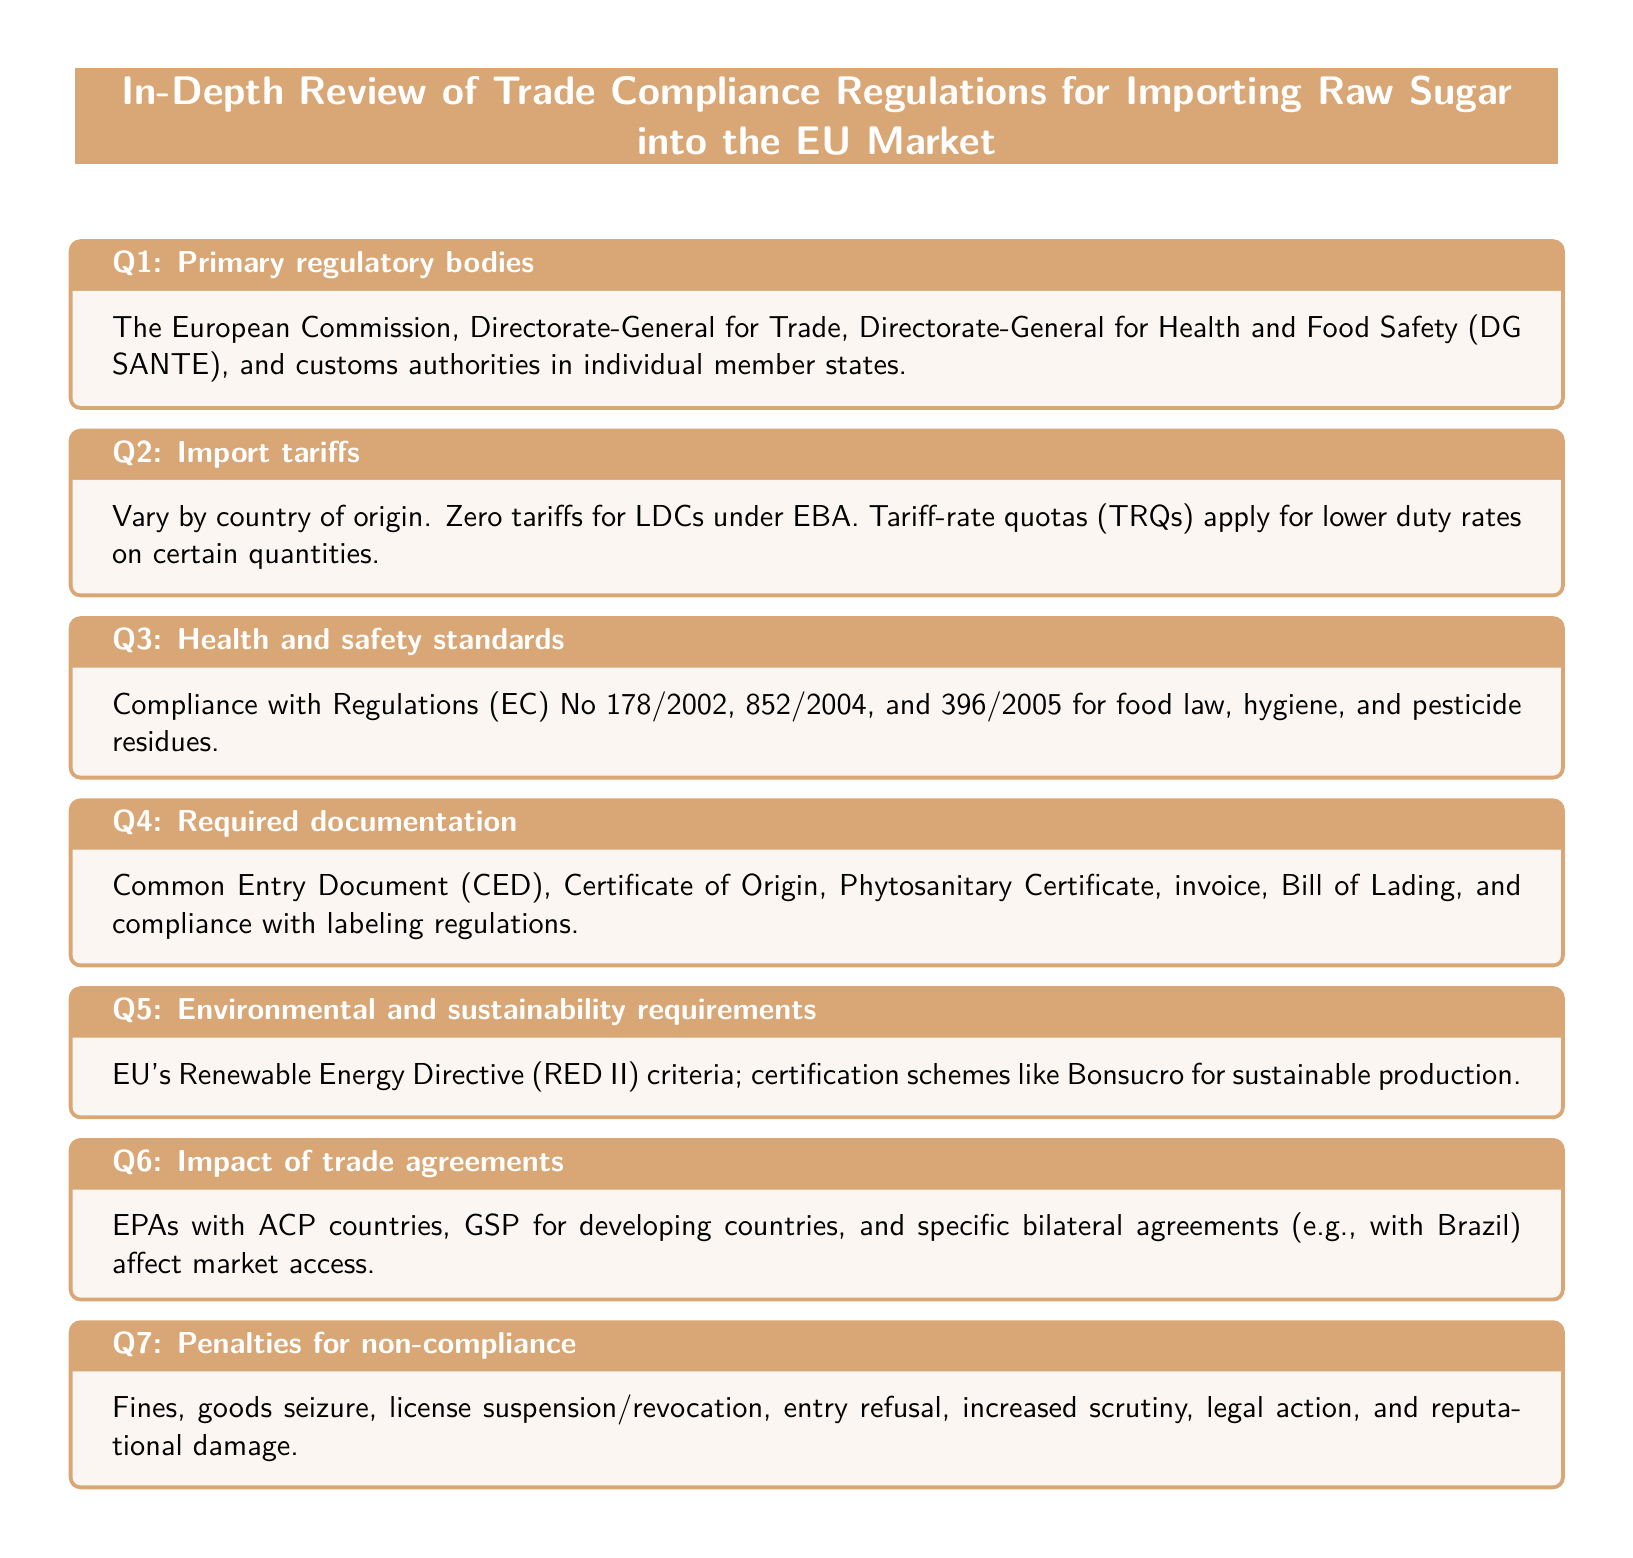What are the primary regulatory bodies? The primary regulatory bodies are listed in Q1 of the document.
Answer: European Commission, Directorate-General for Trade, Directorate-General for Health and Food Safety, customs authorities What is the zero tariff benefit? The zero tariff benefit for LDCs is mentioned in Q2 of the document.
Answer: EBA What regulations govern health and safety standards? The relevant regulations for health and safety are outlined in Q3 of the document.
Answer: Regulations (EC) No 178/2002, 852/2004, and 396/2005 What documentation is required for importing raw sugar? The required documentation is specified in Q4 of the document.
Answer: Common Entry Document, Certificate of Origin, Phytosanitary Certificate, invoice, Bill of Lading What environmental criteria must be met? The environmental criteria are highlighted in Q5 of the document.
Answer: EU's Renewable Energy Directive (RED II) criteria What trade agreements influence market access? The trade agreements affecting market access are discussed in Q6 of the document.
Answer: EPAs with ACP countries, GSP for developing countries What are the penalties for non-compliance? The penalties for non-compliance are outlined in Q7 of the document.
Answer: Fines, goods seizure, license suspension, entry refusal, legal action, reputational damage 